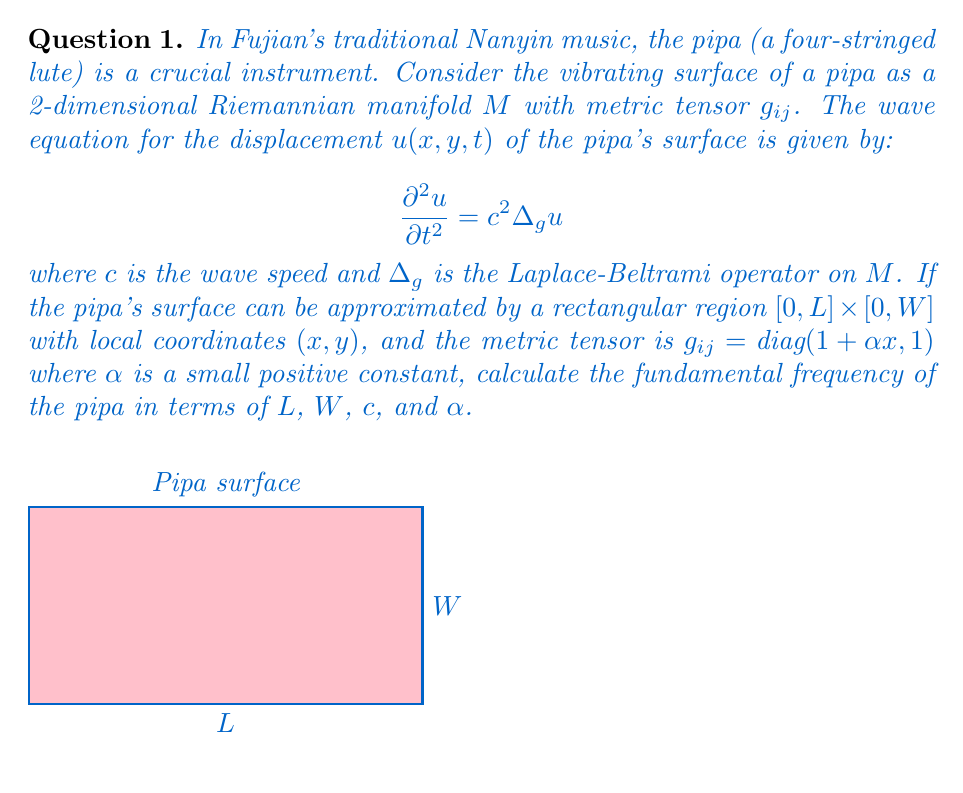Can you solve this math problem? Let's approach this step-by-step:

1) The Laplace-Beltrami operator in local coordinates is given by:

   $$\Delta_g u = \frac{1}{\sqrt{|g|}} \frac{\partial}{\partial x^i} \left(\sqrt{|g|} g^{ij} \frac{\partial u}{\partial x^j}\right)$$

2) For our metric, $g_{11} = 1+\alpha x$, $g_{22} = 1$, and $g_{12} = g_{21} = 0$. The determinant is:

   $$|g| = (1+\alpha x) \cdot 1 = 1+\alpha x$$

3) The inverse metric is $g^{11} = \frac{1}{1+\alpha x}$, $g^{22} = 1$, and $g^{12} = g^{21} = 0$.

4) Substituting into the Laplace-Beltrami operator:

   $$\Delta_g u = \frac{1}{\sqrt{1+\alpha x}} \left[\frac{\partial}{\partial x}\left(\frac{\sqrt{1+\alpha x}}{1+\alpha x}\frac{\partial u}{\partial x}\right) + \frac{\partial}{\partial y}\left(\sqrt{1+\alpha x}\frac{\partial u}{\partial y}\right)\right]$$

5) The wave equation becomes:

   $$\frac{\partial^2 u}{\partial t^2} = c^2 \frac{1}{\sqrt{1+\alpha x}} \left[\frac{\partial}{\partial x}\left(\frac{\sqrt{1+\alpha x}}{1+\alpha x}\frac{\partial u}{\partial x}\right) + \frac{\partial}{\partial y}\left(\sqrt{1+\alpha x}\frac{\partial u}{\partial y}\right)\right]$$

6) For small $\alpha$, we can approximate $\sqrt{1+\alpha x} \approx 1 + \frac{\alpha x}{2}$ and $\frac{1}{1+\alpha x} \approx 1 - \alpha x$.

7) The equation simplifies to:

   $$\frac{\partial^2 u}{\partial t^2} \approx c^2 \left[(1-\frac{\alpha x}{2})\frac{\partial^2 u}{\partial x^2} + \frac{\partial^2 u}{\partial y^2} - \frac{\alpha}{2}\frac{\partial u}{\partial x}\right]$$

8) We seek separable solutions of the form $u(x,y,t) = X(x)Y(y)T(t)$. The time part gives $T(t) = \cos(\omega t)$, where $\omega$ is the angular frequency.

9) For the spatial part, we have boundary conditions $u=0$ at $x=0$, $x=L$, $y=0$, and $y=W$. This gives:

   $$X(x) \approx \sin\left(\frac{n\pi x}{L}\right), \quad Y(y) = \sin\left(\frac{m\pi y}{W}\right)$$

   where $n$ and $m$ are positive integers.

10) Substituting back and equating coefficients, we get:

    $$\omega^2 \approx c^2 \left[\left(\frac{n\pi}{L}\right)^2 + \left(\frac{m\pi}{W}\right)^2\right] - c^2\frac{\alpha L}{4}\left(\frac{n\pi}{L}\right)^2$$

11) The fundamental frequency corresponds to $n=m=1$:

    $$f = \frac{\omega}{2\pi} \approx \frac{c}{2}\sqrt{\left(\frac{1}{L}\right)^2 + \left(\frac{1}{W}\right)^2 - \frac{\alpha}{4L^2}}$$
Answer: $f \approx \frac{c}{2}\sqrt{\left(\frac{1}{L}\right)^2 + \left(\frac{1}{W}\right)^2 - \frac{\alpha}{4L^2}}$ 